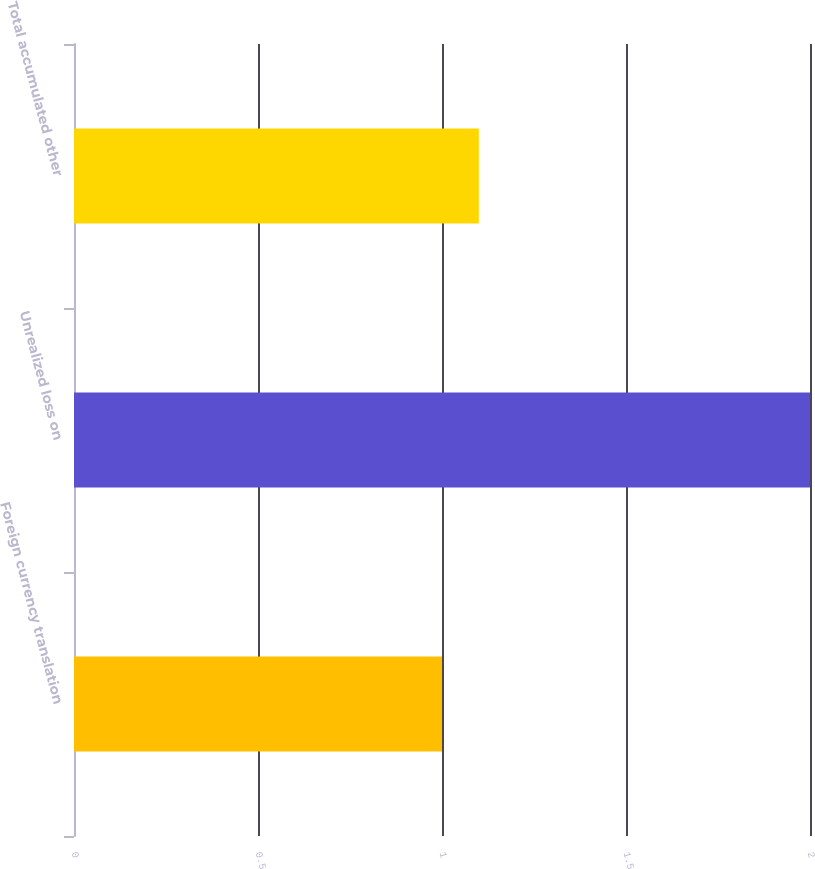Convert chart to OTSL. <chart><loc_0><loc_0><loc_500><loc_500><bar_chart><fcel>Foreign currency translation<fcel>Unrealized loss on<fcel>Total accumulated other<nl><fcel>1<fcel>2<fcel>1.1<nl></chart> 